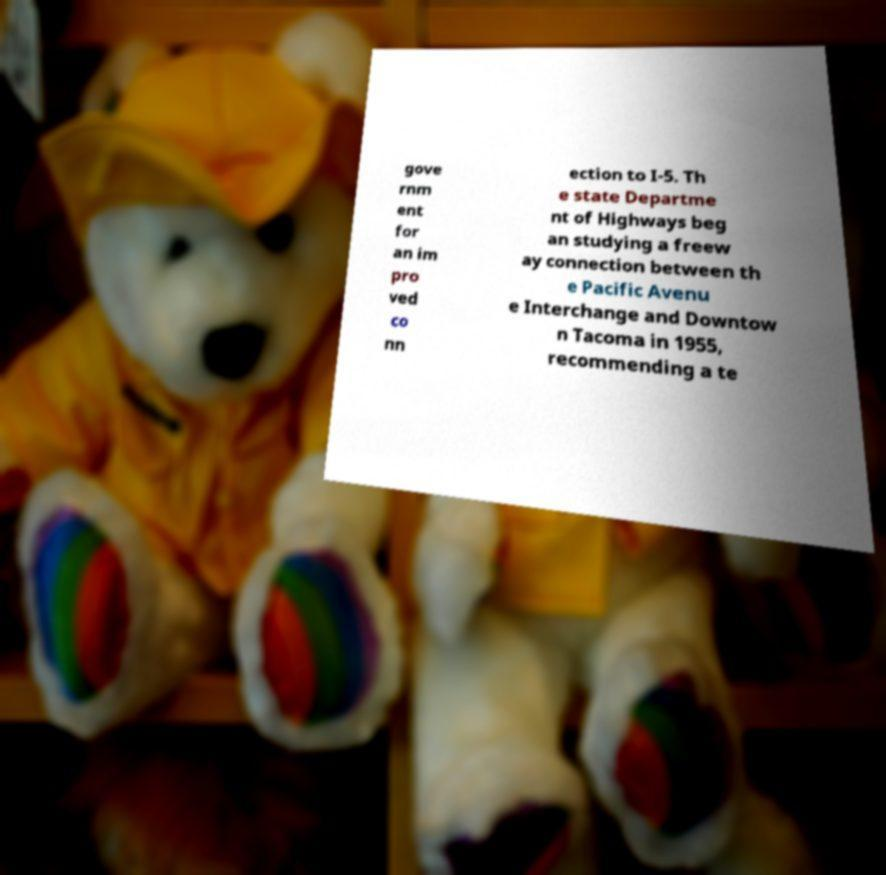There's text embedded in this image that I need extracted. Can you transcribe it verbatim? gove rnm ent for an im pro ved co nn ection to I-5. Th e state Departme nt of Highways beg an studying a freew ay connection between th e Pacific Avenu e Interchange and Downtow n Tacoma in 1955, recommending a te 